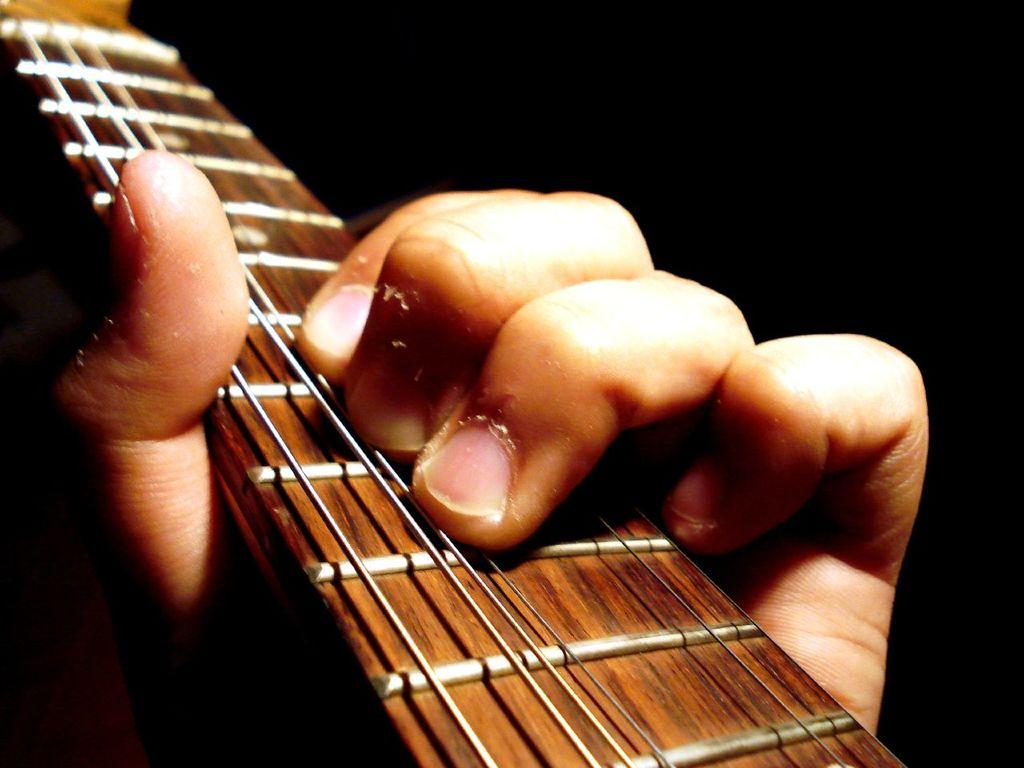What is the person's hand holding in the image? The person's hand is holding a guitar. Can you describe the guitar in the image? The guitar is also partially visible in the image. What is the color of the background in the image? The background of the image is dark. Where was the image taken? The image was taken inside a hall. What type of tin can be seen on the desk in the image? There is no tin or desk present in the image; it only features a person's hand holding a guitar. 